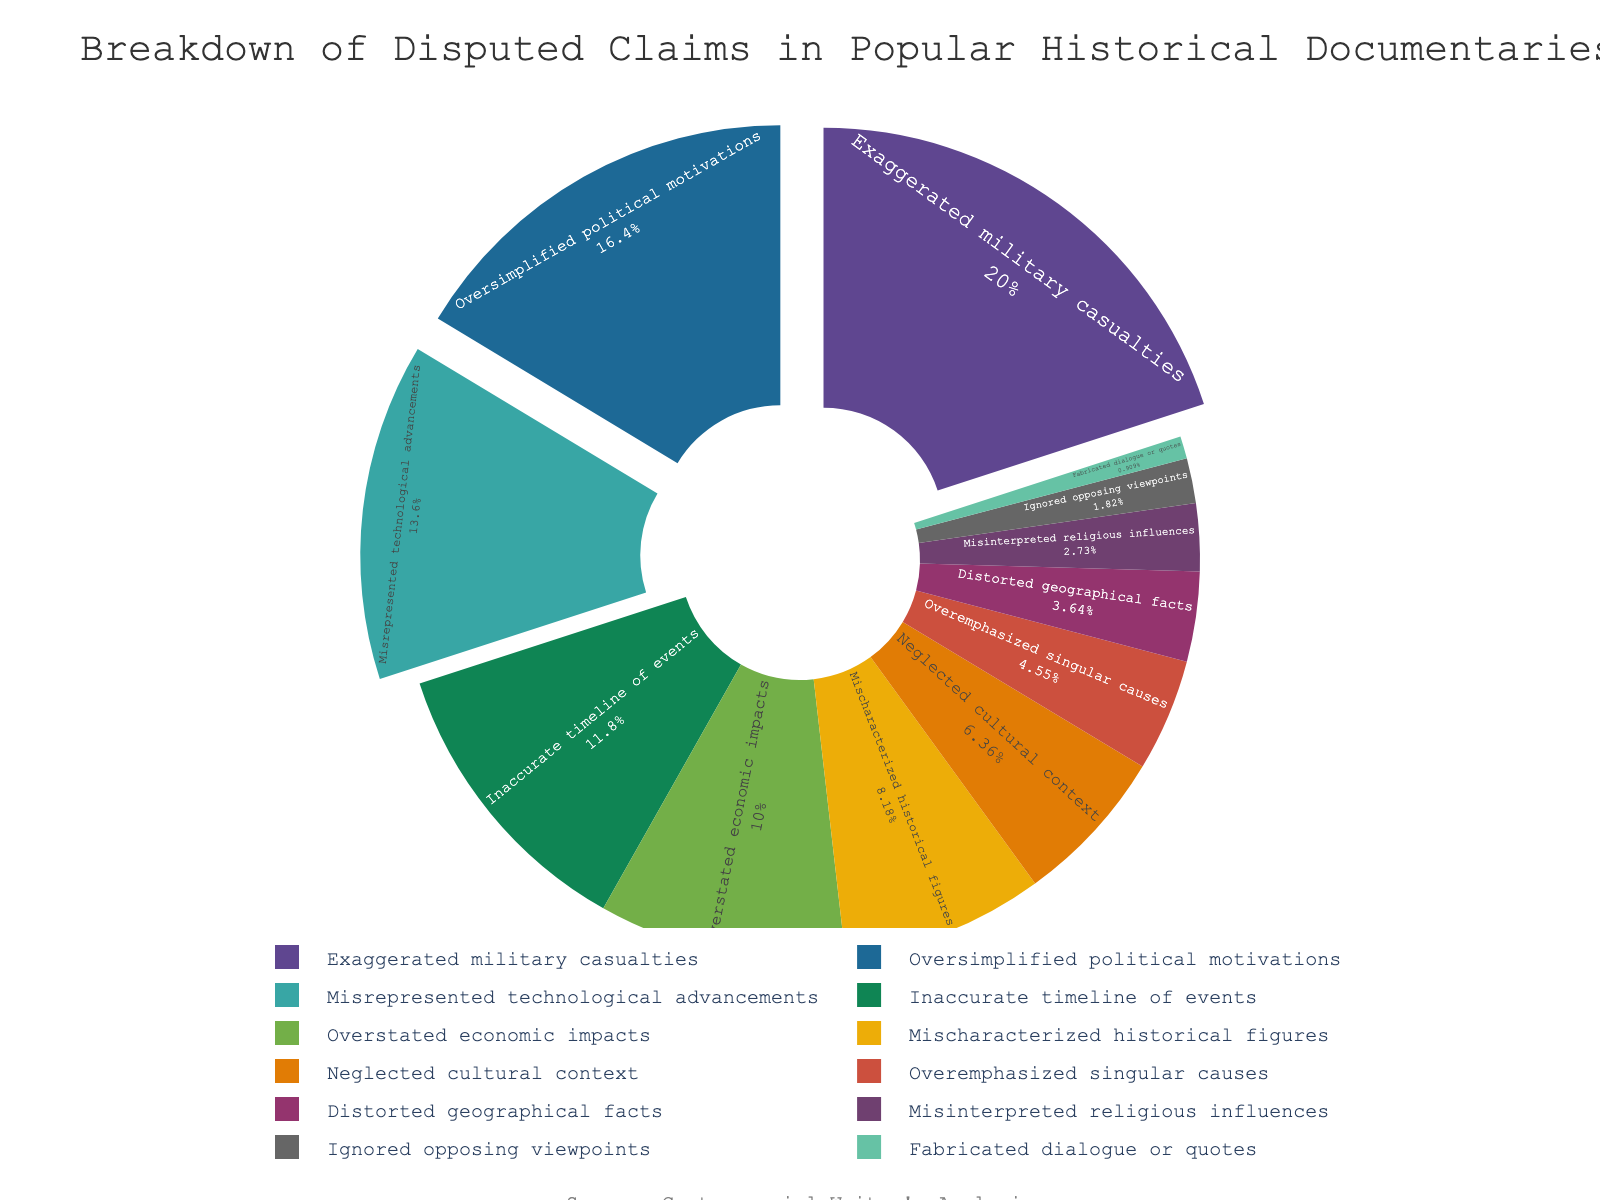Which category accounts for the highest percentage of disputed claims? The category with the largest section of the pie chart is "Exaggerated military casualties" which has the largest wedge.
Answer: Exaggerated military casualties What is the total percentage of claims related to both "Misrepresented technological advancements" and "Oversimplified political motivations"? Add the percentages of "Misrepresented technological advancements" (15%) and "Oversimplified political motivations" (18%). 15 + 18 = 33
Answer: 33 Which has a smaller percentage, "Neglected cultural context" or "Overstated economic impacts"? Compare the sizes of the relevant wedges. "Neglected cultural context" has 7% while "Overstated economic impacts" has 11%. 7% < 11%
Answer: Neglected cultural context What is the median percentage value among all the categories? Order all percentages: 1, 2, 3, 4, 5, 7, 9, 11, 13, 15, 18, 22. Find the middle value(s). Since there are 12 categories, the median is the average of the 6th and 7th values: (7 + 9) / 2 = 8
Answer: 8 Which category is represented with a color closer to yellow in the pie chart? Since the exact color palette is not described, the answer can only be approximated based on common usage of yellow. "Misrepresented technological advancements" is generally depicted in a lighter color like yellow in visual representations.
Answer: Misrepresented technological advancements How much larger is the percentage for "Exaggerated military casualties" compared to "Overemphasized singular causes"? Subtract the percentage of "Overemphasized singular causes" (5%) from "Exaggerated military casualties" (22%). 22 - 5 = 17
Answer: 17 Are there more categories with a percentage lower than 10% or higher than 10%? Count the categories with percentages below and above 10%. Below 10%: 1, 2, 3, 4, 5, 7, 9 (7 categories). Above 10%: 11, 13, 15, 18, 22 (5 categories).
Answer: Lower than 10% What portion of the chart represents inaccuracies due to misinterpretations, combining "Misinterpreted religious influences" and "Mischaracterized historical figures"? Add the percentages of "Misinterpreted religious influences" (3%) and "Mischaracterized historical figures" (9%). 3 + 9 = 12
Answer: 12 What's the sum of the percentages for the three smallest wedges? Identify the three smallest wedges: "Fabricated dialogue or quotes" (1%), "Ignored opposing viewpoints" (2%), "Misinterpreted religious influences" (3%). Sum them up: 1 + 2 + 3 = 6
Answer: 6 